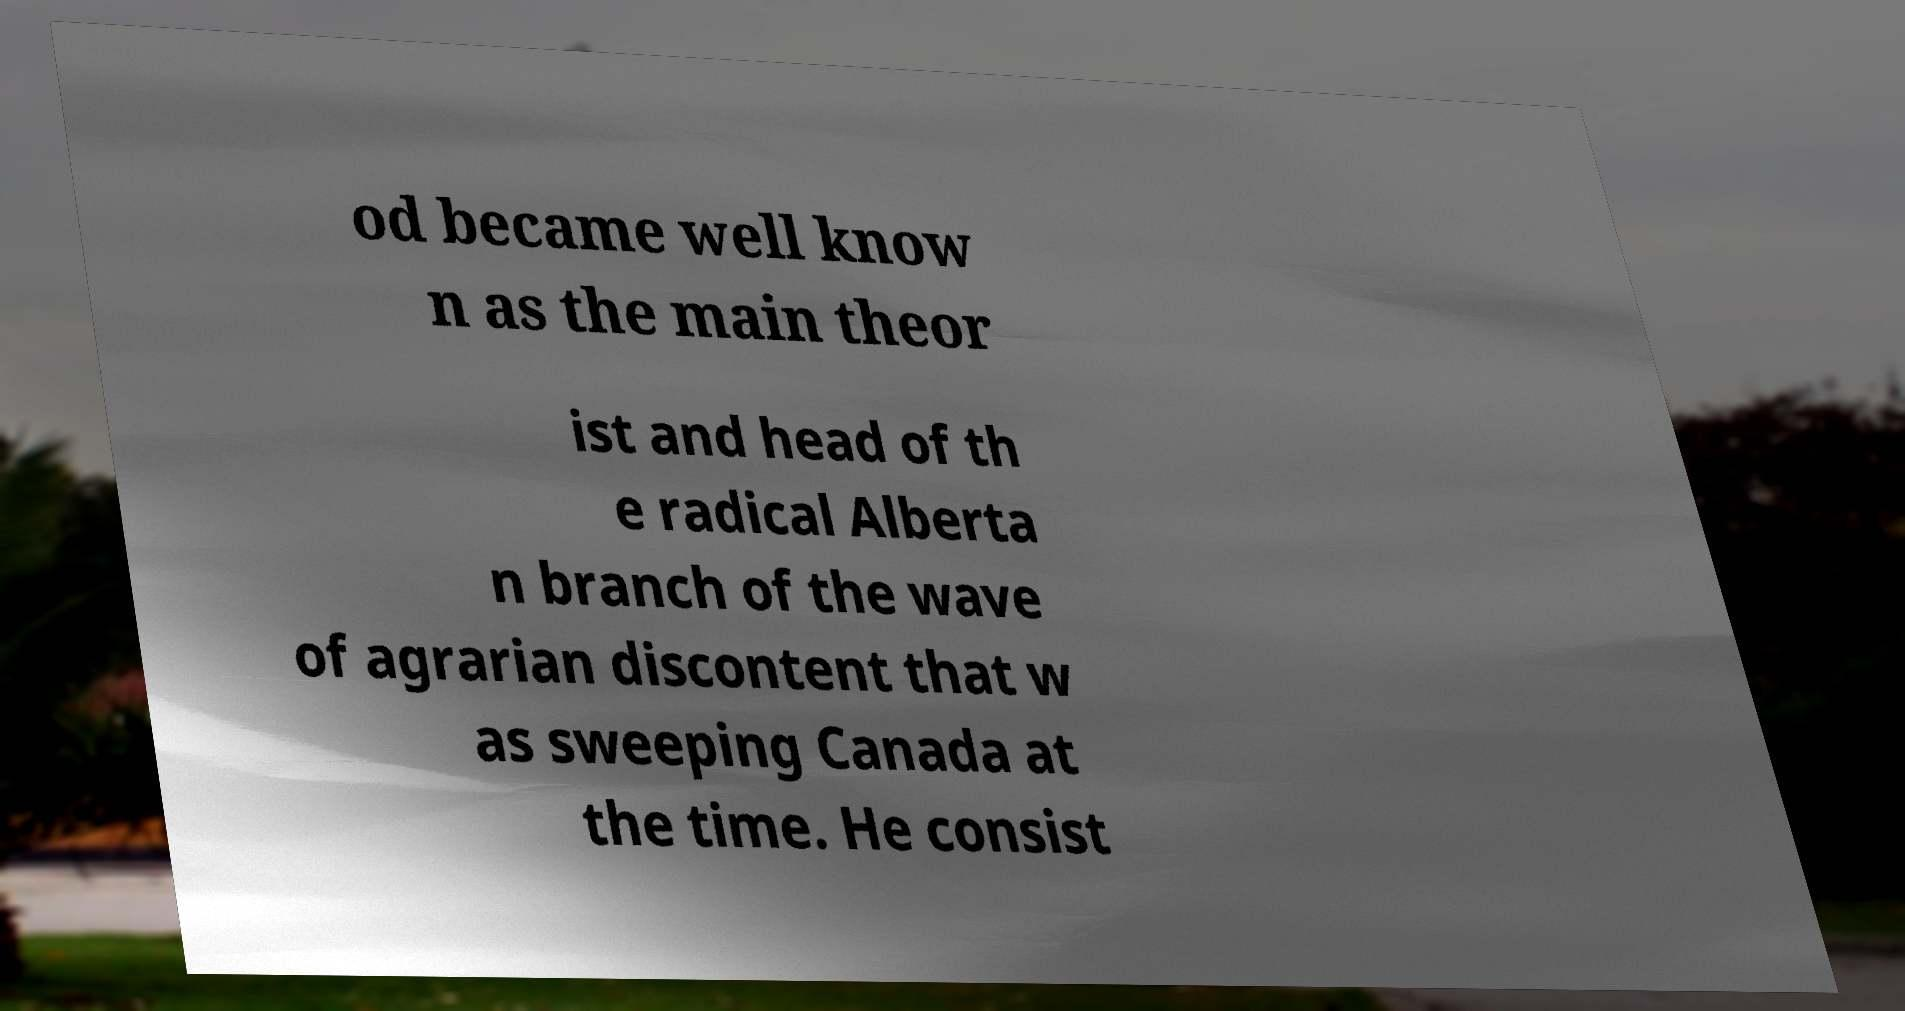There's text embedded in this image that I need extracted. Can you transcribe it verbatim? od became well know n as the main theor ist and head of th e radical Alberta n branch of the wave of agrarian discontent that w as sweeping Canada at the time. He consist 